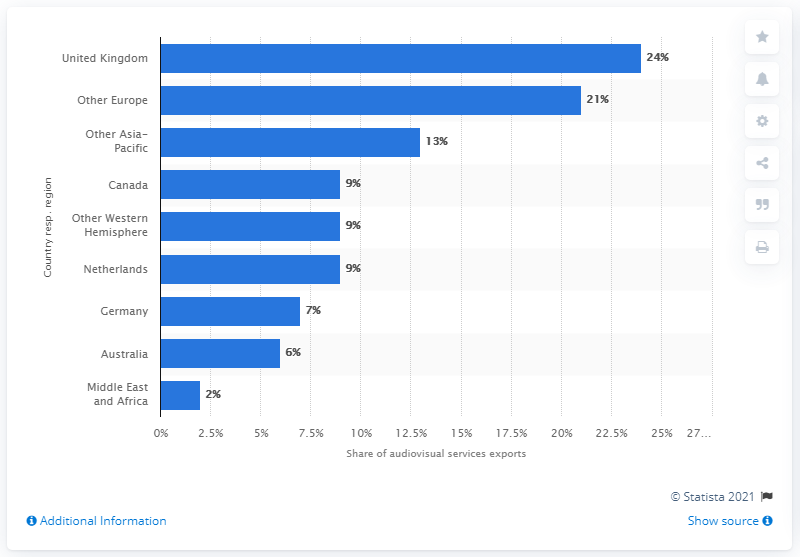Point out several critical features in this image. In 2012, 24% of audiovisual services were exported to the United Kingdom. 